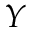<formula> <loc_0><loc_0><loc_500><loc_500>Y</formula> 